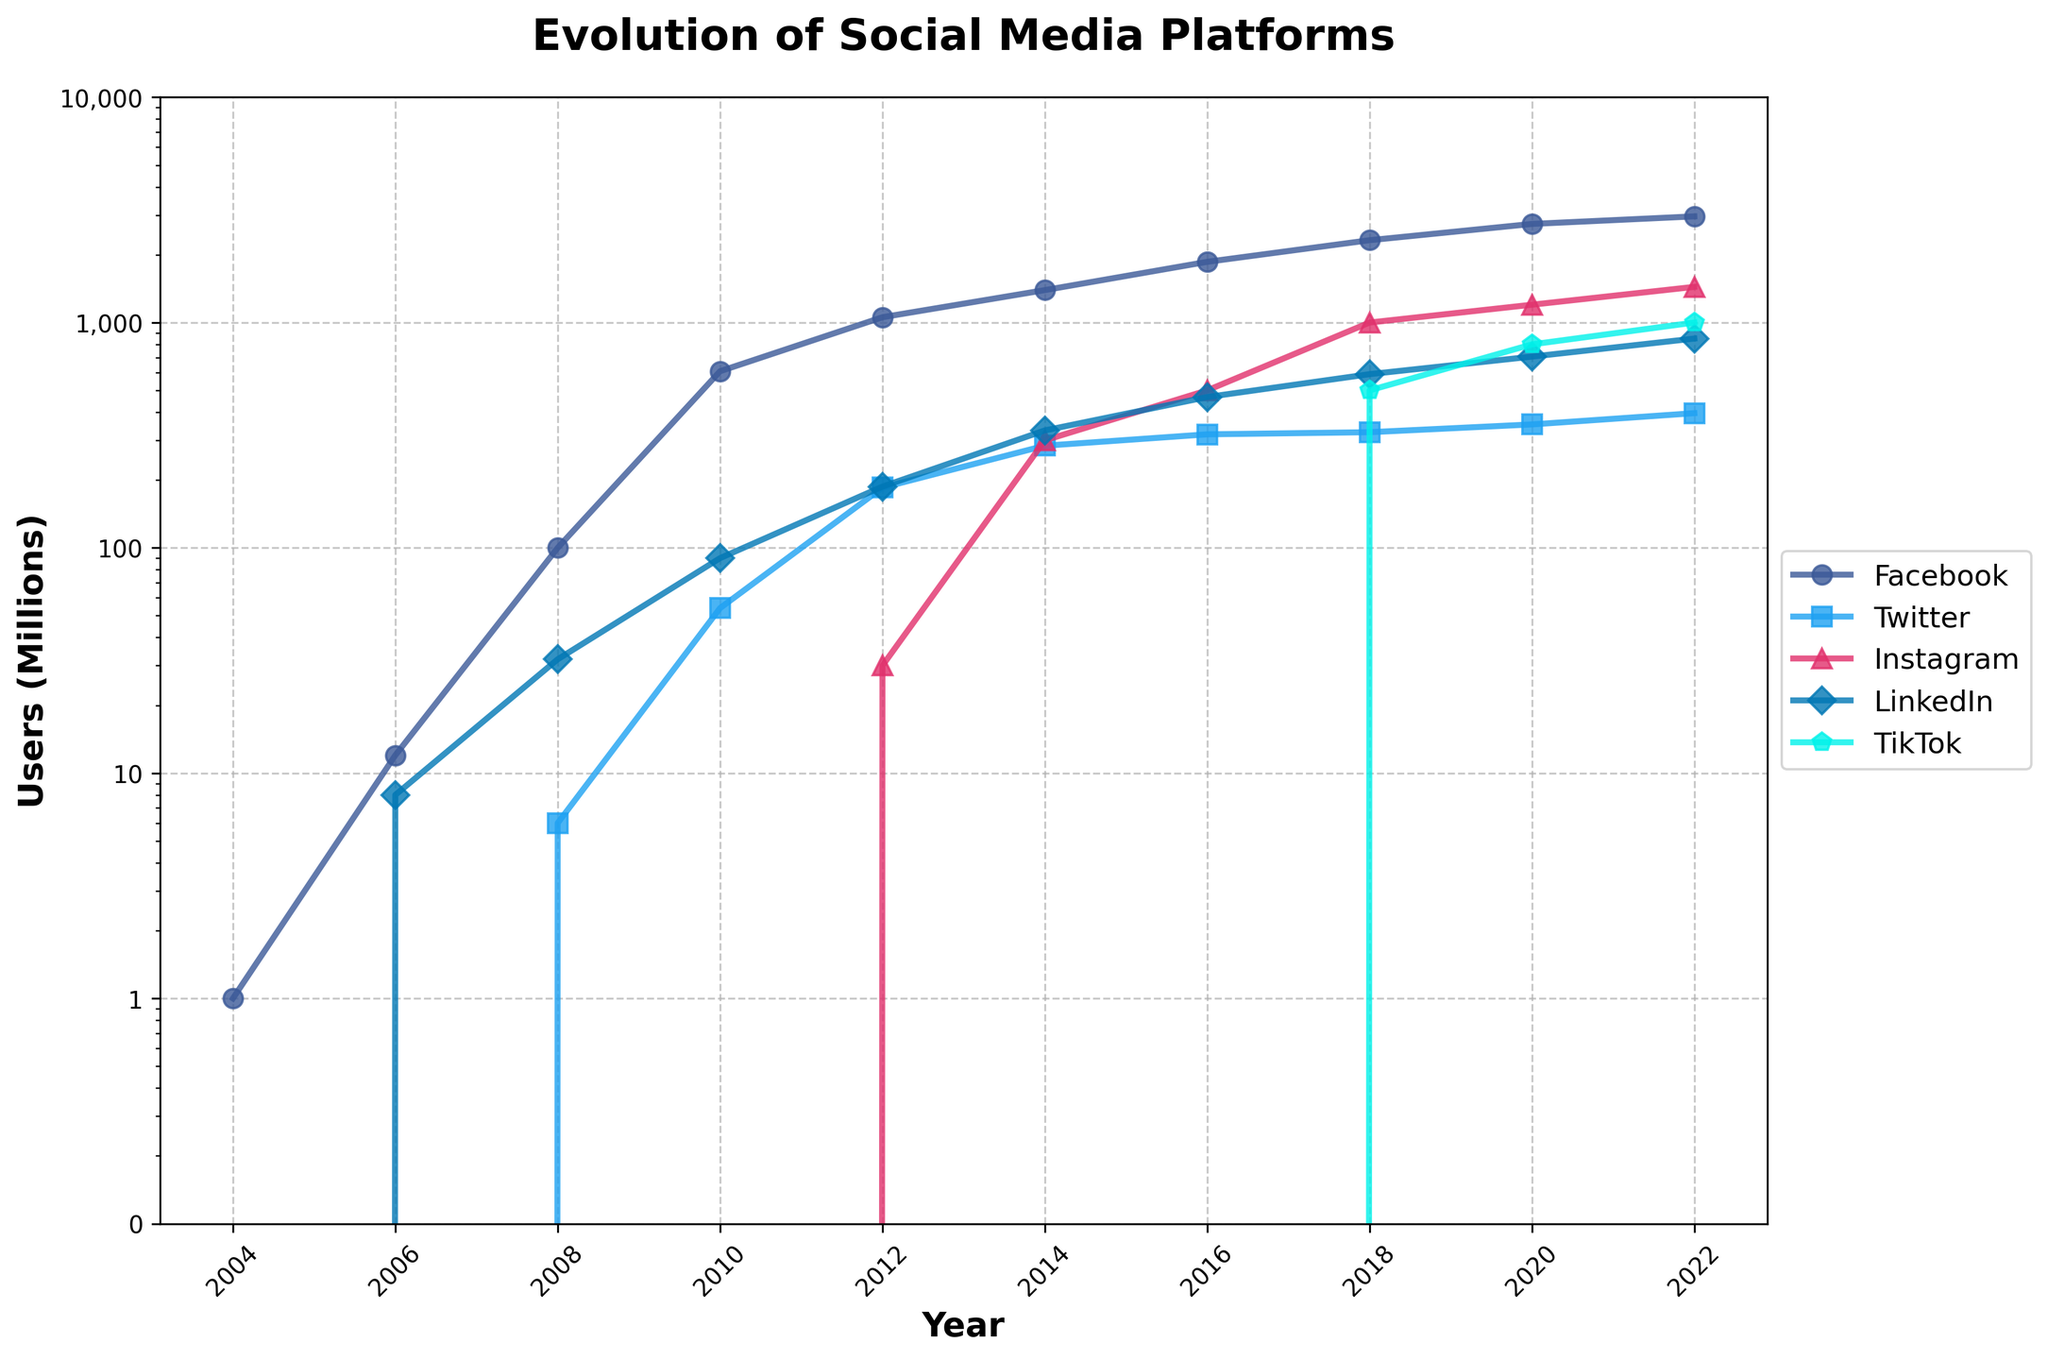Which social media platform had the highest user count in 2018? In the figure, observe the markers at the year 2018. Facebook, Twitter, Instagram, LinkedIn, and TikTok are represented by different colors and shapes. Instagram, marked with a triangle (^) and colored in pink, has the highest point in 2018.
Answer: Instagram How many millions of users did LinkedIn have in 2022 and how does it compare to Twitter in the same year? In 2022, LinkedIn has a point at 849 million users (labelled with a diamond shape and colored blue), whereas Twitter has a point at 396 million users (labelled with a square shape and colored light blue). LinkedIn has more users than Twitter.
Answer: LinkedIn: 849 million, more than Twitter What was the user count growth for Instagram from 2014 to 2018? In 2014, Instagram had 300 million users as shown by the pink triangle (^). In 2018, the user count is 1000 million. So, the growth is calculated as 1000 million - 300 million = 700 million.
Answer: 700 million Which platform saw the most significant increase in user count between 2018 and 2020? Comparing the lines between 2018 and 2020, TikTok (represented by a light blue pentagon marker) shows a steep increase from 500 million to 800 million users, a growth of 300 million users. Other platforms increased by smaller margins.
Answer: TikTok Did TikTok surpass Twitter in user counts by 2020, and by how much? In 2020, TikTok has a point at 800 million users, while Twitter has a point at 353 million users (both represented by markers of different shapes and colors). The difference is calculated as 800 million - 353 million = 447 million.
Answer: Yes, by 447 million Which two platforms had similar user counts in 2014, and what were their counts? In 2014, observe the markers for LinkedIn and Twitter. Both have user points close to 300 million. LinkedIn has 332 million users and Twitter has 284 million users.
Answer: LinkedIn: 332 million, Twitter: 284 million From 2008 to 2012, by how much did Facebook's user count increase? In 2008, Facebook had 100 million users (marked with the Facebook blue circle). In 2012, the user count increased to 1056 million users. Difference: 1056 million - 100 million = 956 million.
Answer: 956 million What is the trend for Instagram from its inception to 2022? Instagram starts from 0 users and rises steadily over the years. Its markers start appearing from 2012 (30 million) and continue to increase up to 2022 (1440 million). The trend shows rapid growth.
Answer: Rapid growth How does the user count for Facebook in 2006 compare to LinkedIn in 2006? In 2006, Facebook has a point at 12 million users, while LinkedIn has a point at 8 million users. Facebook has more users.
Answer: Facebook: 12 million, more than LinkedIn: 8 million Based on the data for 2022, rank the platforms from highest to lowest user counts. For 2022: Facebook (2960 million), Instagram (1440 million), LinkedIn (849 million), TikTok (1000 million), and Twitter (396 million). Ordered from highest to lowest, it is: Facebook, Instagram, TikTok, LinkedIn, Twitter.
Answer: Facebook > Instagram > TikTok > LinkedIn > Twitter 